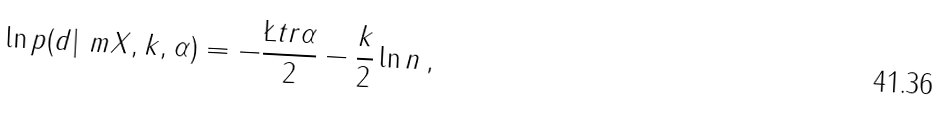Convert formula to latex. <formula><loc_0><loc_0><loc_500><loc_500>\ln p ( d | \ m X , k , \alpha ) = - \frac { \L t r { \alpha } } { 2 } - \frac { k } { 2 } \ln n \, ,</formula> 